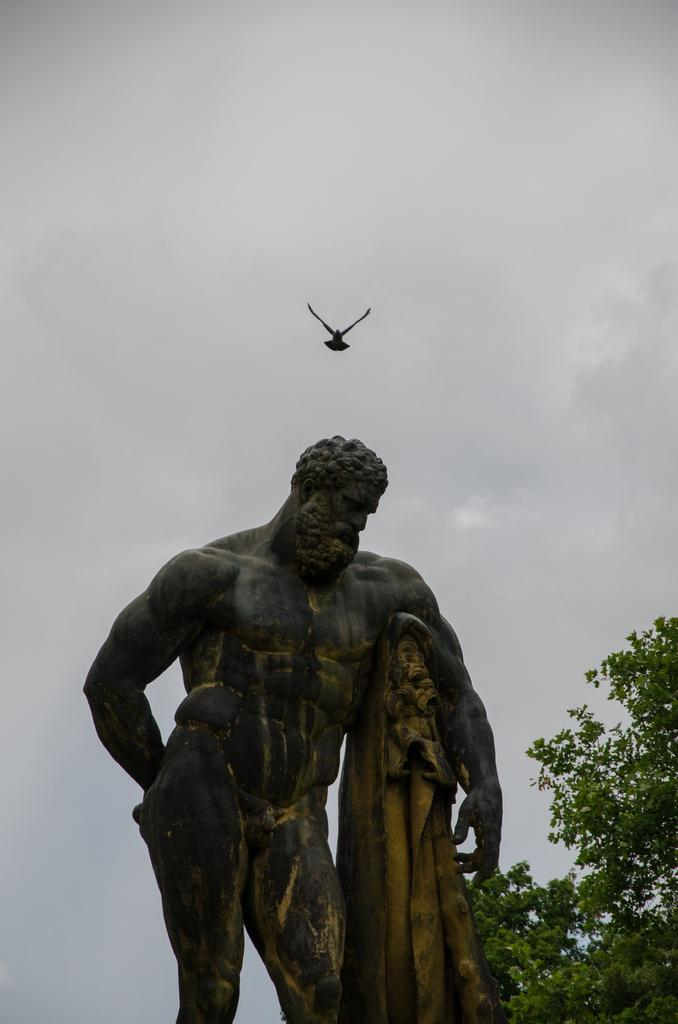What is the main subject in the image? There is a statue in the image. What can be seen in the background of the image? There are trees in the background of the image. What is the color of the trees? The trees are green. What other living creature is visible in the image? There is a bird visible in the image. What is the color of the sky in the image? The sky is white in color. What verse is being recited by the statue in the image? There is no verse being recited by the statue in the image, as it is a statue and not a living being capable of speech. 